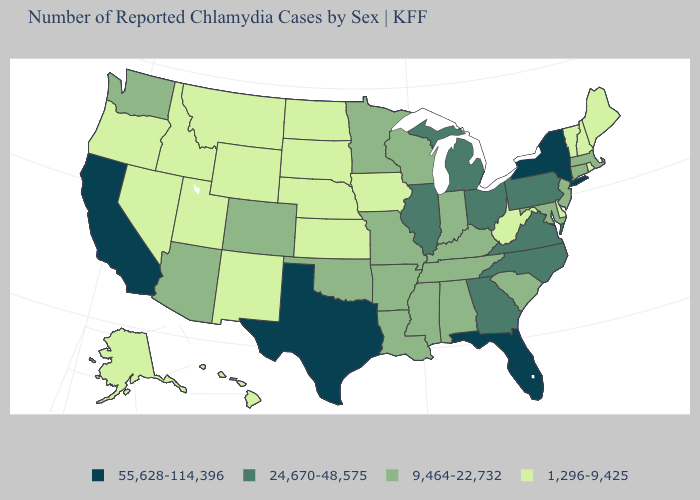Does South Dakota have the lowest value in the USA?
Concise answer only. Yes. Among the states that border Indiana , does Illinois have the highest value?
Keep it brief. Yes. Name the states that have a value in the range 1,296-9,425?
Keep it brief. Alaska, Delaware, Hawaii, Idaho, Iowa, Kansas, Maine, Montana, Nebraska, Nevada, New Hampshire, New Mexico, North Dakota, Oregon, Rhode Island, South Dakota, Utah, Vermont, West Virginia, Wyoming. What is the value of Colorado?
Short answer required. 9,464-22,732. What is the value of Connecticut?
Keep it brief. 9,464-22,732. Name the states that have a value in the range 9,464-22,732?
Be succinct. Alabama, Arizona, Arkansas, Colorado, Connecticut, Indiana, Kentucky, Louisiana, Maryland, Massachusetts, Minnesota, Mississippi, Missouri, New Jersey, Oklahoma, South Carolina, Tennessee, Washington, Wisconsin. What is the value of Wisconsin?
Write a very short answer. 9,464-22,732. What is the value of Virginia?
Write a very short answer. 24,670-48,575. Name the states that have a value in the range 9,464-22,732?
Answer briefly. Alabama, Arizona, Arkansas, Colorado, Connecticut, Indiana, Kentucky, Louisiana, Maryland, Massachusetts, Minnesota, Mississippi, Missouri, New Jersey, Oklahoma, South Carolina, Tennessee, Washington, Wisconsin. Is the legend a continuous bar?
Give a very brief answer. No. What is the value of Missouri?
Write a very short answer. 9,464-22,732. What is the value of Tennessee?
Quick response, please. 9,464-22,732. Name the states that have a value in the range 55,628-114,396?
Quick response, please. California, Florida, New York, Texas. Does Ohio have the lowest value in the USA?
Write a very short answer. No. What is the highest value in the Northeast ?
Quick response, please. 55,628-114,396. 